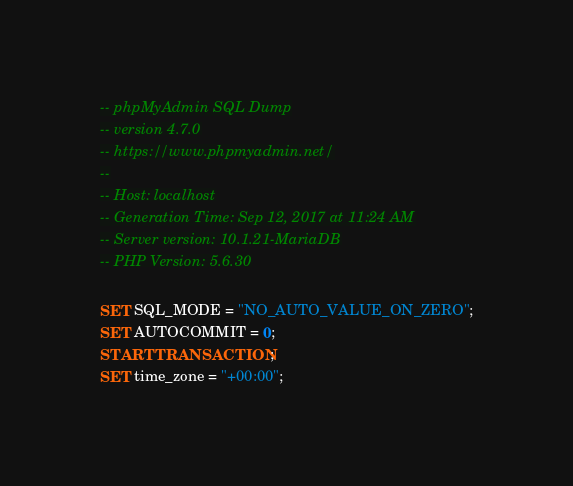Convert code to text. <code><loc_0><loc_0><loc_500><loc_500><_SQL_>-- phpMyAdmin SQL Dump
-- version 4.7.0
-- https://www.phpmyadmin.net/
--
-- Host: localhost
-- Generation Time: Sep 12, 2017 at 11:24 AM
-- Server version: 10.1.21-MariaDB
-- PHP Version: 5.6.30

SET SQL_MODE = "NO_AUTO_VALUE_ON_ZERO";
SET AUTOCOMMIT = 0;
START TRANSACTION;
SET time_zone = "+00:00";

</code> 